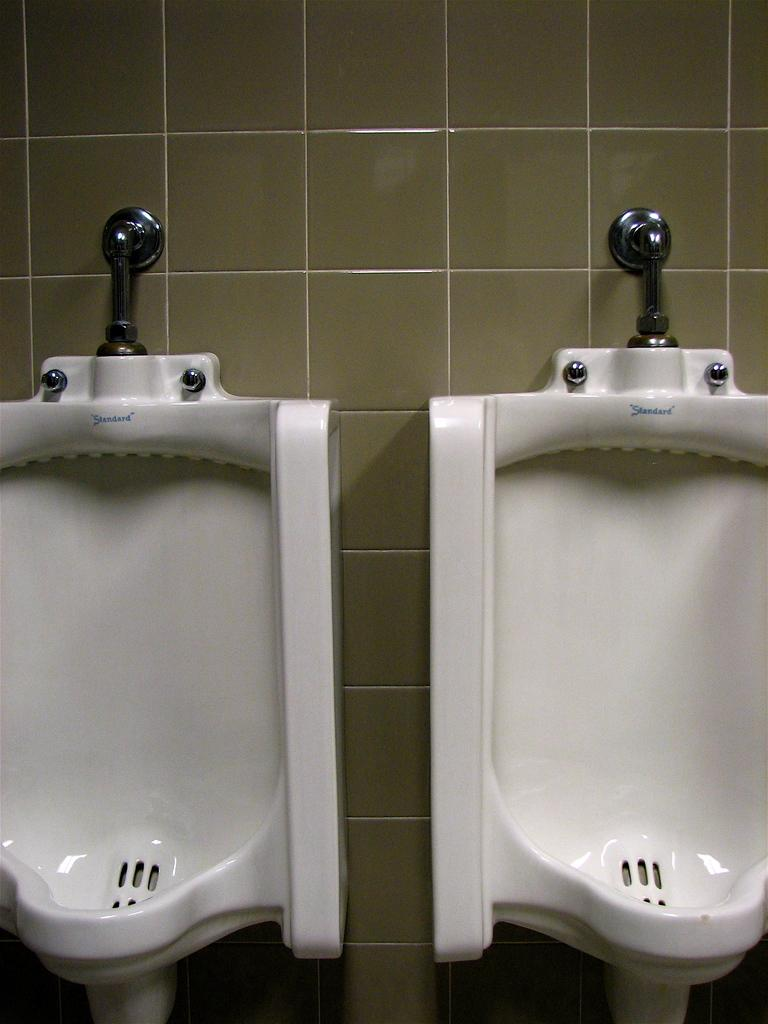What objects can be seen in the image? There are rods, a tile wall, and urinals in the image. Can you describe the wall in the image? The wall in the image is made of tiles. What might the rods be used for? The purpose of the rods is not explicitly stated, but they could be used for hanging or supporting items. How many babies are crawling on the tile wall in the image? There are no babies present in the image; it only features rods, a tile wall, and urinals. 